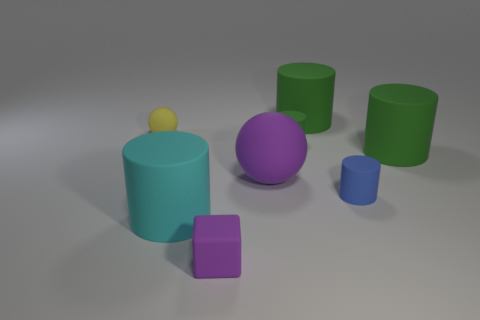Subtract all tiny cylinders. How many cylinders are left? 3 Add 2 purple spheres. How many objects exist? 10 Subtract all blue cylinders. How many cylinders are left? 4 Subtract all gray cubes. How many green cylinders are left? 3 Subtract all cylinders. How many objects are left? 3 Subtract 1 cylinders. How many cylinders are left? 4 Add 2 tiny green cylinders. How many tiny green cylinders exist? 3 Subtract 1 purple balls. How many objects are left? 7 Subtract all yellow balls. Subtract all green blocks. How many balls are left? 1 Subtract all yellow matte spheres. Subtract all purple rubber blocks. How many objects are left? 6 